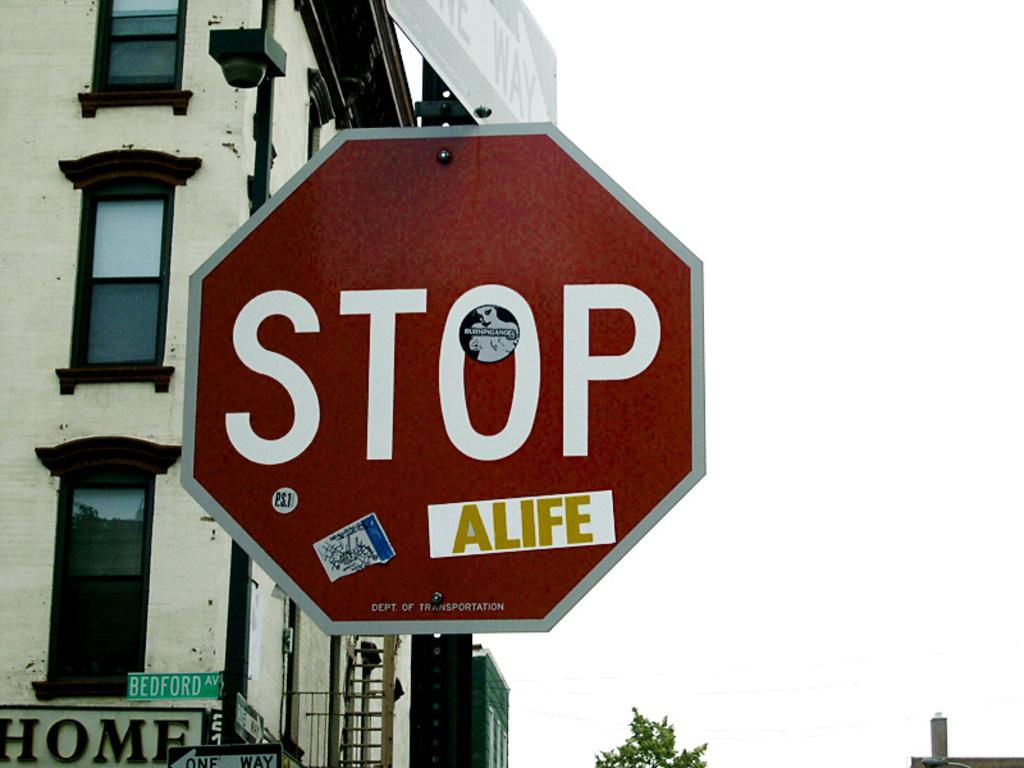<image>
Give a short and clear explanation of the subsequent image. a stop sign that is outside in the daytime 